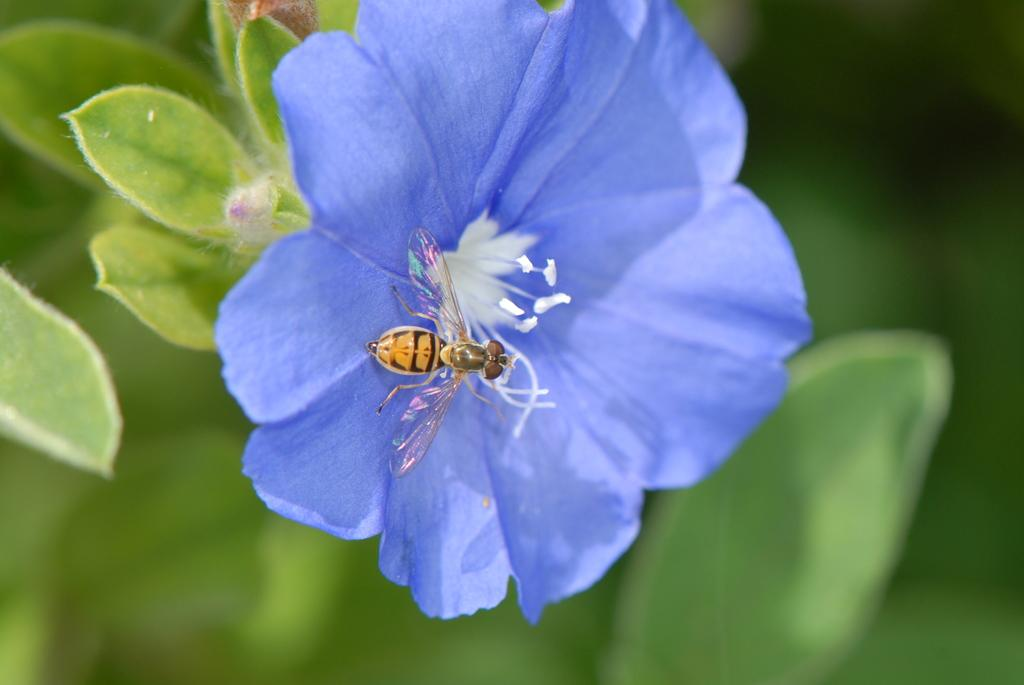What is the insect on in the image? There is an insect on a flower in the image. What type of vegetation is present in the image? There are green leaves in the image. Can you describe the background of the image? The background of the image is blurred. What year is depicted in the image? There is no specific year depicted in the image; it features an insect on a flower and green leaves. Is there a carpenter working on the flower in the image? There is no carpenter present in the image; it features an insect on a flower and green leaves. 